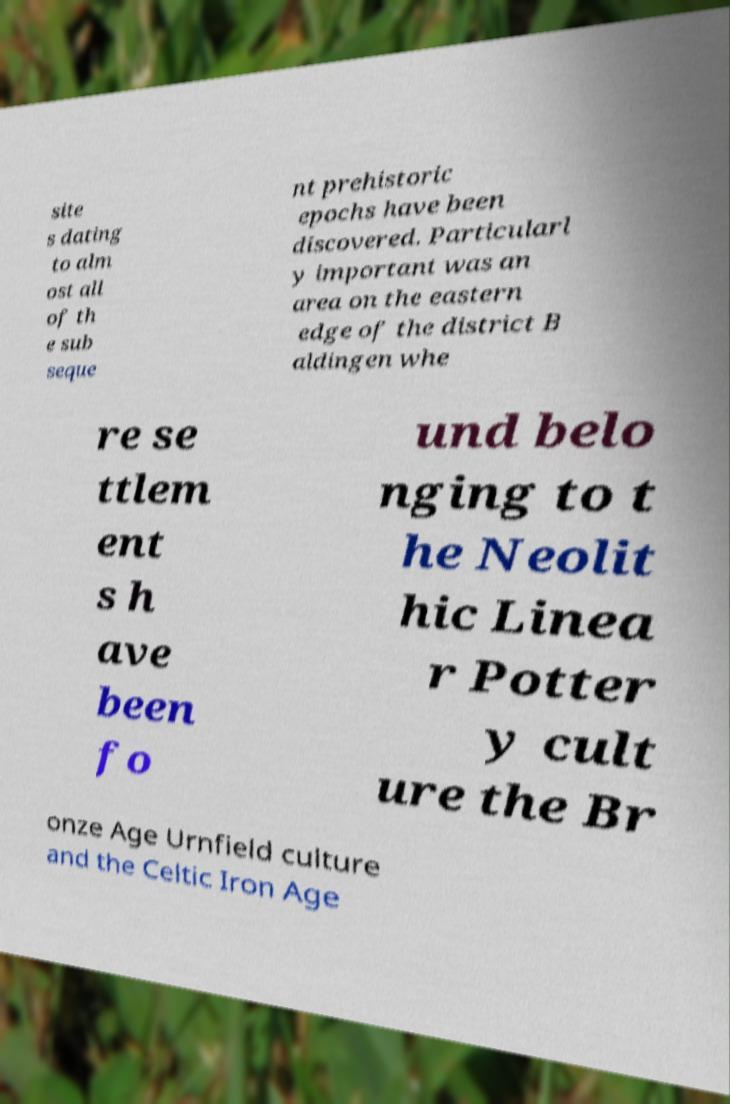Could you extract and type out the text from this image? site s dating to alm ost all of th e sub seque nt prehistoric epochs have been discovered. Particularl y important was an area on the eastern edge of the district B aldingen whe re se ttlem ent s h ave been fo und belo nging to t he Neolit hic Linea r Potter y cult ure the Br onze Age Urnfield culture and the Celtic Iron Age 